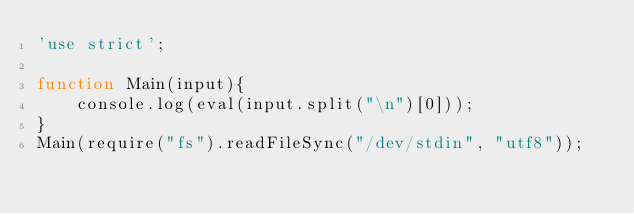Convert code to text. <code><loc_0><loc_0><loc_500><loc_500><_JavaScript_>'use strict';
 
function Main(input){
    console.log(eval(input.split("\n")[0]));
}
Main(require("fs").readFileSync("/dev/stdin", "utf8"));</code> 